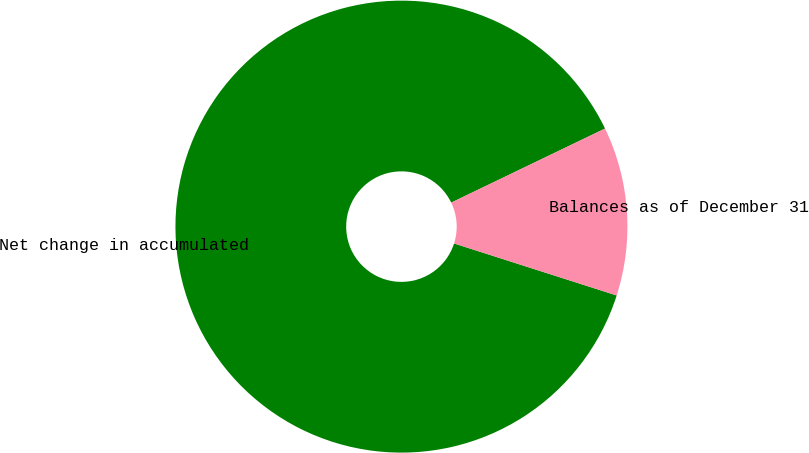Convert chart. <chart><loc_0><loc_0><loc_500><loc_500><pie_chart><fcel>Net change in accumulated<fcel>Balances as of December 31<nl><fcel>87.93%<fcel>12.07%<nl></chart> 